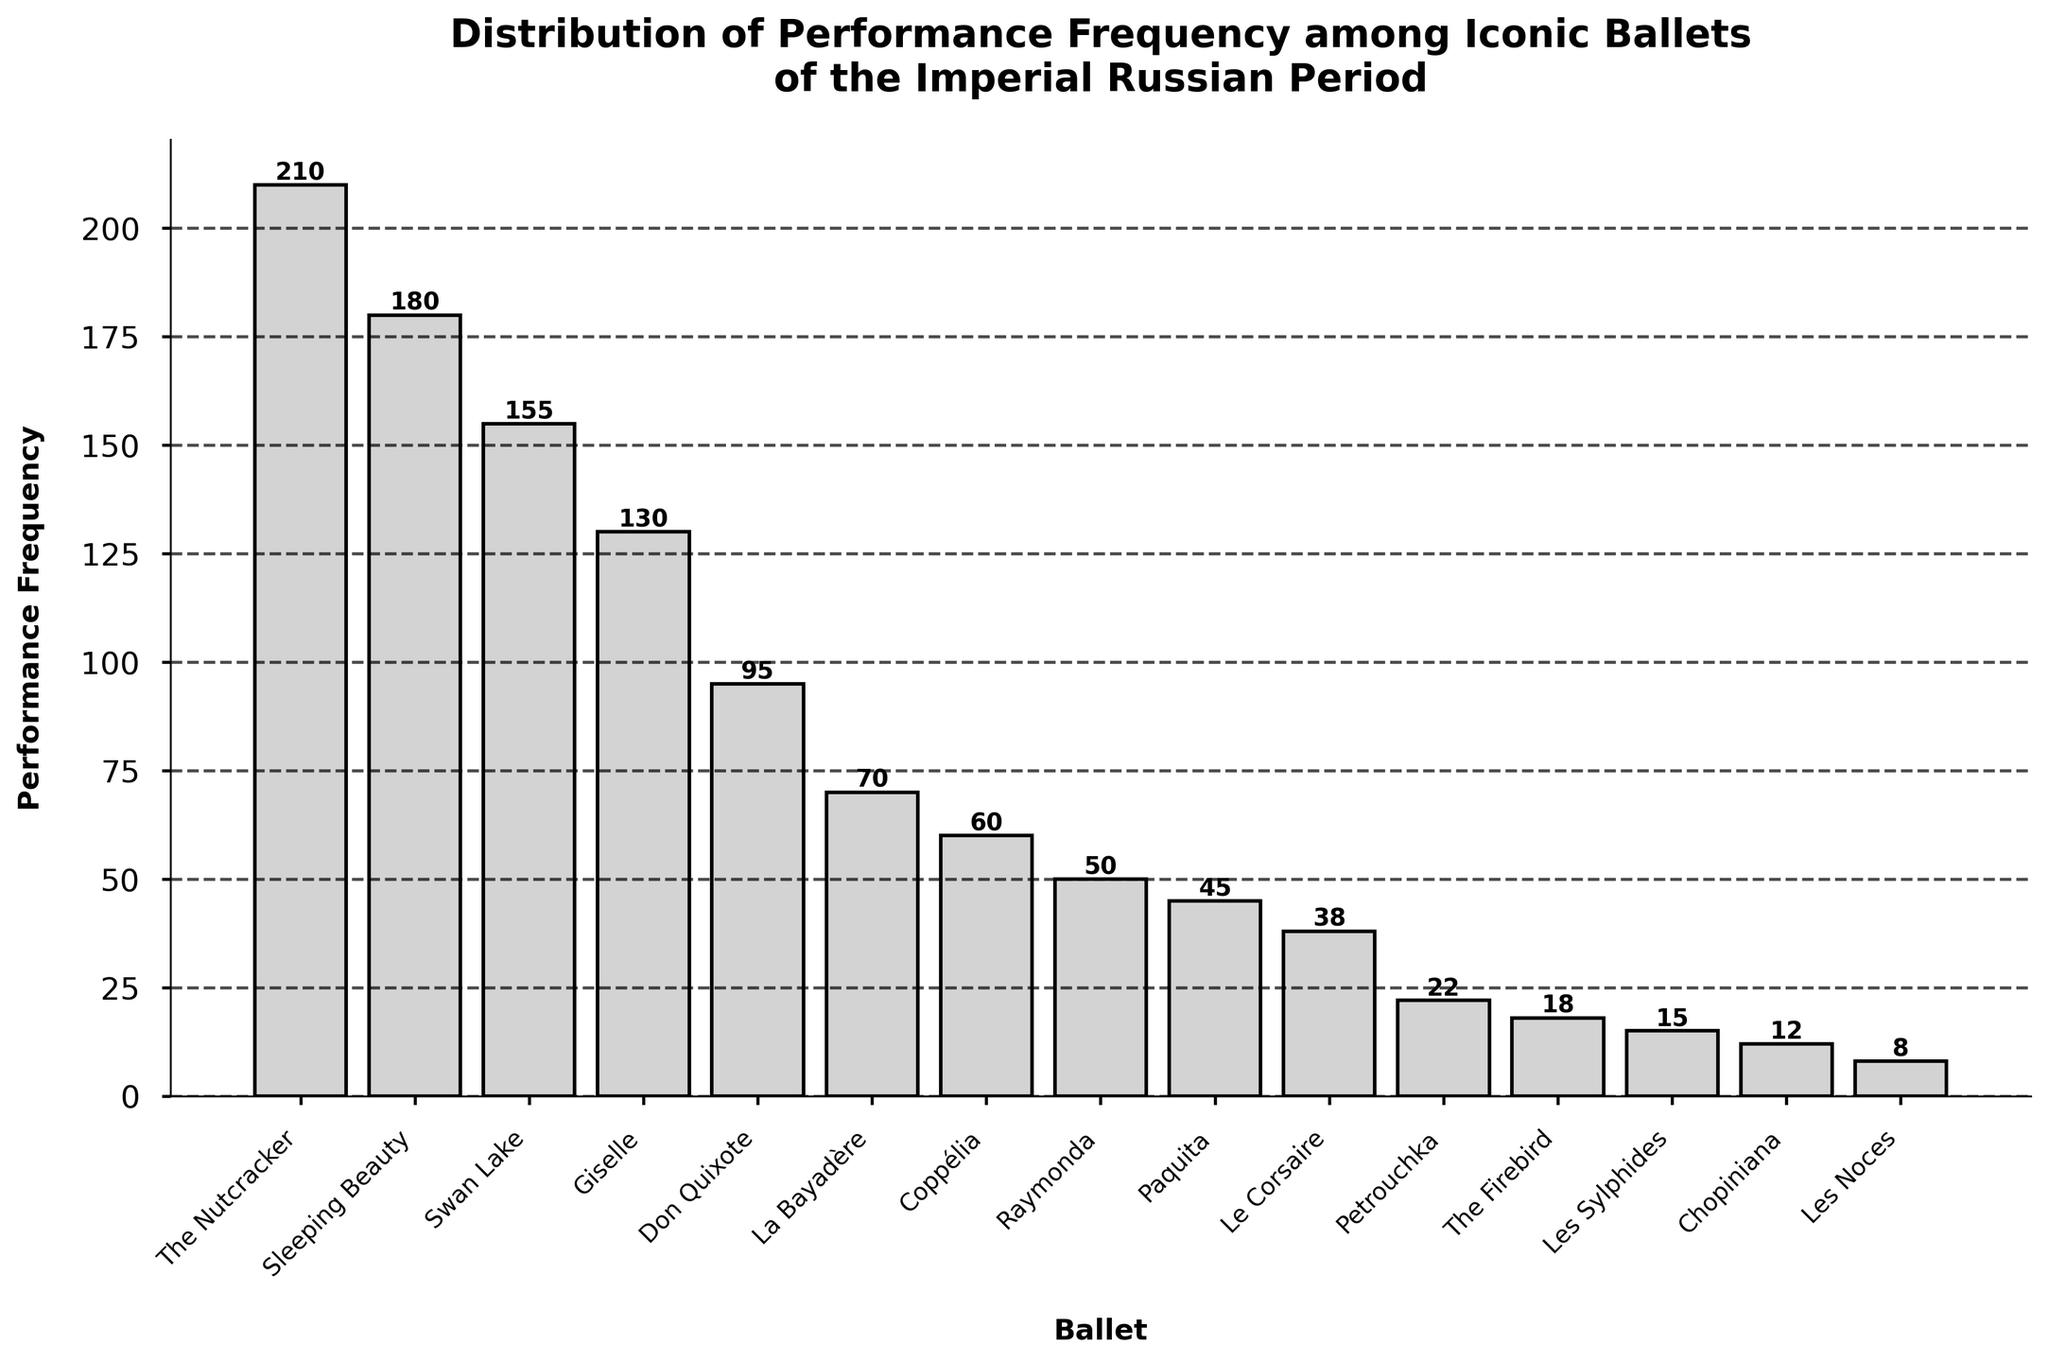What is the title of the plot? The title of the plot is displayed prominently at the top of the figure. It reads, "Distribution of Performance Frequency among Iconic Ballets of the Imperial Russian Period".
Answer: Distribution of Performance Frequency among Iconic Ballets of the Imperial Russian Period Which ballet has the highest performance frequency? By examining the heights of the bars, "The Nutcracker" has the highest performance frequency. It is the tallest bar.
Answer: The Nutcracker How many ballets have a performance frequency greater than 100? The bars that are taller than the 100 mark on the y-axis represent the ballets with frequencies greater than 100. These ballets are "Swan Lake", "The Nutcracker", "Sleeping Beauty", and "Giselle".
Answer: 4 What is the difference in performance frequency between "Swan Lake" and "Les Noces"? The performance frequency of "Swan Lake" is 155, and the performance frequency of "Les Noces" is 8. The difference is calculated as 155 - 8.
Answer: 147 Which ballet has the lowest performance frequency and what is it? The shortest bar represents the lowest performance frequency, which corresponds to "Les Noces", with a frequency of 8.
Answer: Les Noces, 8 How does the performance frequency of "Giselle" compare to that of "Raymonda"? "Giselle" has a frequency of 130, whereas "Raymonda" has a frequency of 50. "Giselle" has a higher performance frequency.
Answer: Giselle is higher What is the sum of performance frequencies for "Swan Lake", "The Nutcracker", and "Sleeping Beauty"? Adding up the frequencies, 155 ("Swan Lake") + 210 ("The Nutcracker") + 180 ("Sleeping Beauty") equals 545.
Answer: 545 How many ballets have a performance frequency below 20? The bars representing frequencies below 20 are "Petrouchka" (22), "The Firebird" (18), "Les Sylphides" (15), "Chopiniana" (12), and "Les Noces" (8). The count is 4.
Answer: 4 What is the average performance frequency of the ballets "Don Quixote", "Coppélia", and "La Bayadère"? Average is calculated by adding the frequencies and dividing by the number of ballets. (95 + 60 + 70) / 3 equals 75.
Answer: 75 Identify the ballet with a performance frequency closest to 50. By looking at the bars, the ballet with a frequency closest to 50 is "Raymonda" with a frequency of 50.
Answer: Raymonda 